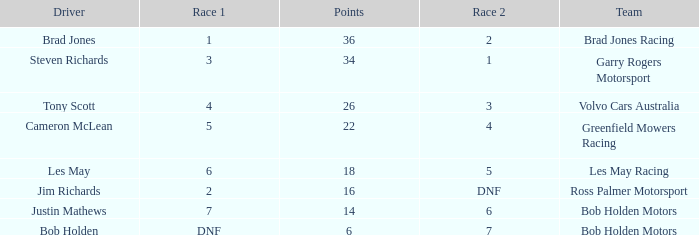Which team received 4 in race 1? Volvo Cars Australia. 